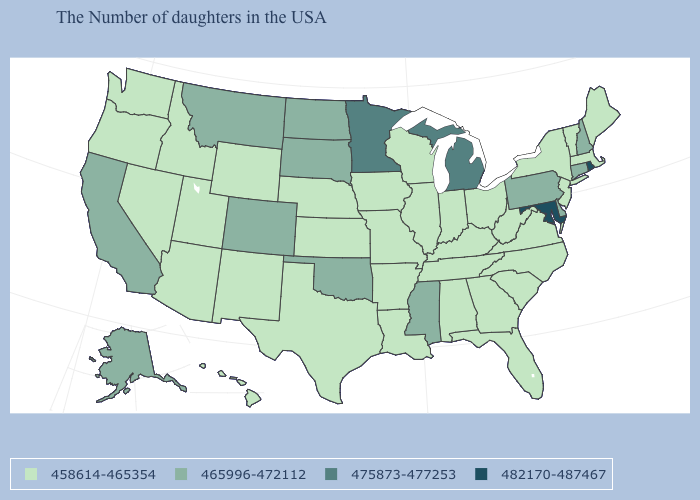Which states have the lowest value in the Northeast?
Quick response, please. Maine, Massachusetts, Vermont, New York, New Jersey. Does the map have missing data?
Write a very short answer. No. How many symbols are there in the legend?
Give a very brief answer. 4. What is the value of Delaware?
Concise answer only. 465996-472112. Which states have the highest value in the USA?
Concise answer only. Rhode Island, Maryland. Name the states that have a value in the range 458614-465354?
Short answer required. Maine, Massachusetts, Vermont, New York, New Jersey, Virginia, North Carolina, South Carolina, West Virginia, Ohio, Florida, Georgia, Kentucky, Indiana, Alabama, Tennessee, Wisconsin, Illinois, Louisiana, Missouri, Arkansas, Iowa, Kansas, Nebraska, Texas, Wyoming, New Mexico, Utah, Arizona, Idaho, Nevada, Washington, Oregon, Hawaii. Does Louisiana have a lower value than New Mexico?
Give a very brief answer. No. Does Massachusetts have a lower value than Pennsylvania?
Write a very short answer. Yes. What is the value of New York?
Quick response, please. 458614-465354. Among the states that border Iowa , does Minnesota have the lowest value?
Quick response, please. No. Which states have the lowest value in the MidWest?
Concise answer only. Ohio, Indiana, Wisconsin, Illinois, Missouri, Iowa, Kansas, Nebraska. Among the states that border West Virginia , which have the lowest value?
Give a very brief answer. Virginia, Ohio, Kentucky. Does Pennsylvania have a higher value than Delaware?
Be succinct. No. What is the highest value in states that border New York?
Be succinct. 465996-472112. Is the legend a continuous bar?
Concise answer only. No. 